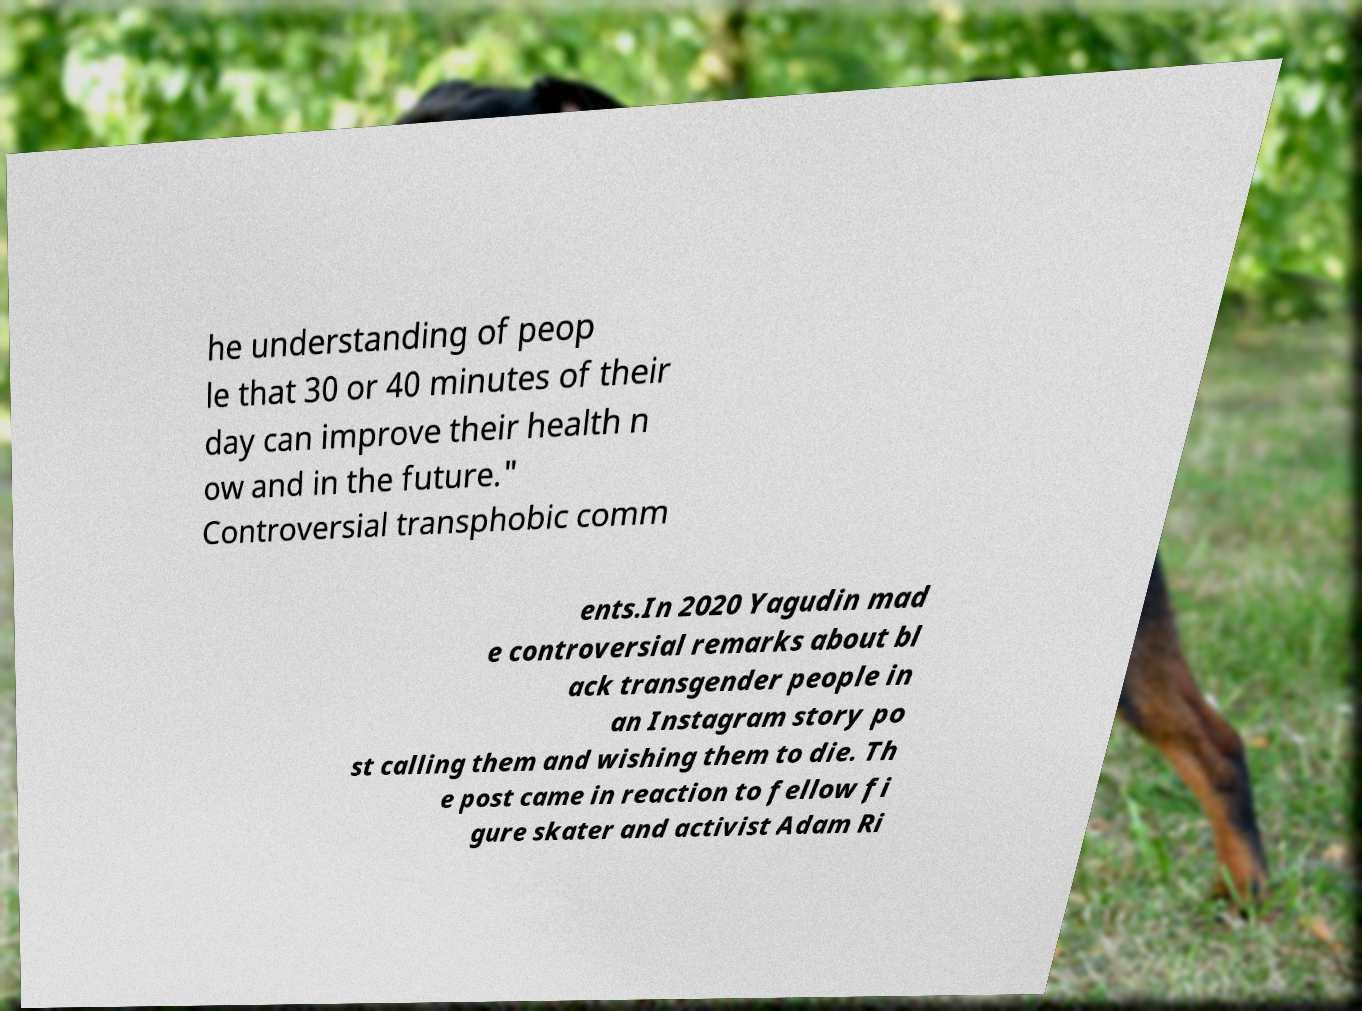Could you extract and type out the text from this image? he understanding of peop le that 30 or 40 minutes of their day can improve their health n ow and in the future." Controversial transphobic comm ents.In 2020 Yagudin mad e controversial remarks about bl ack transgender people in an Instagram story po st calling them and wishing them to die. Th e post came in reaction to fellow fi gure skater and activist Adam Ri 